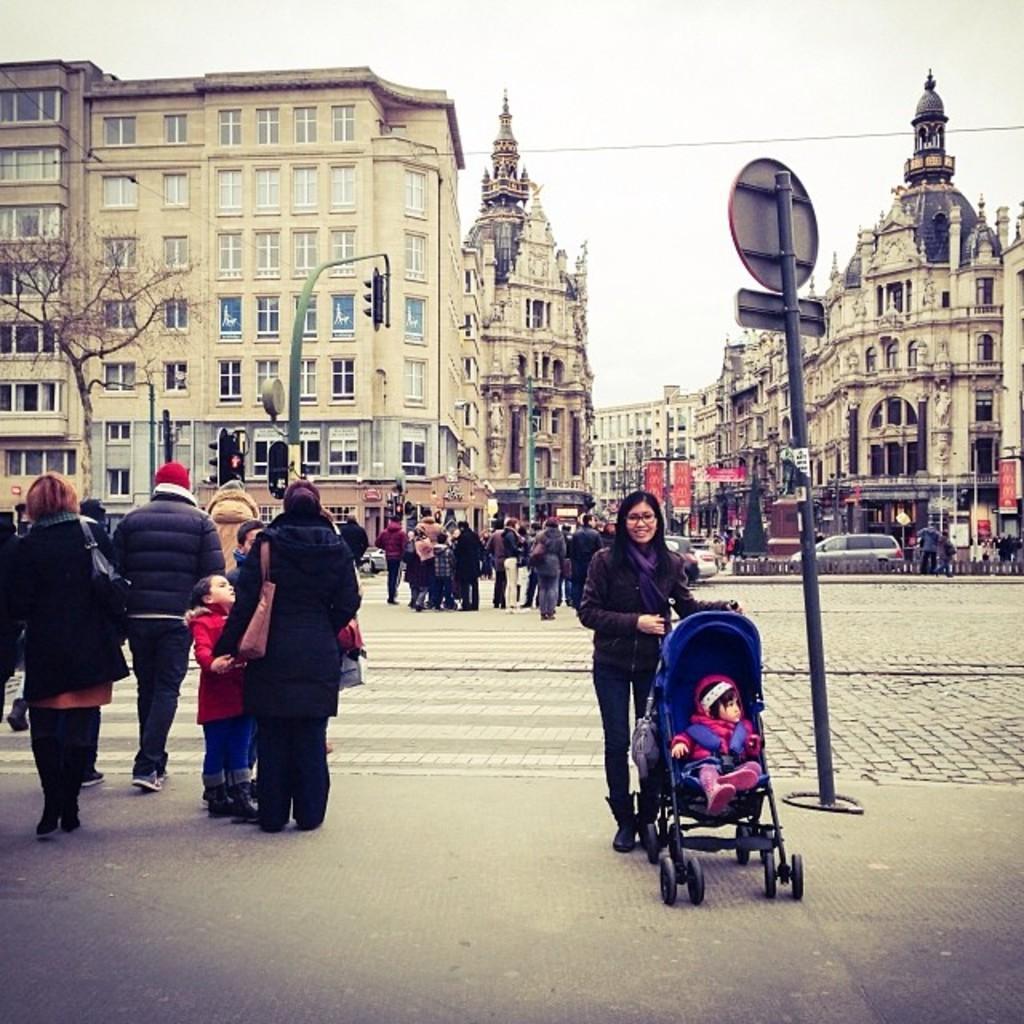Please provide a concise description of this image. In this image there is a woman standing on the footpath by holding the cradle. On the left side there are few people who are walking on the zebra crossing. In the background there are so many buildings. On the road there are vehicles. On the right side there is a pole on the footpath. At the top there is the sky. On the left side there is a tree. In the middle there is a traffic signal light. 